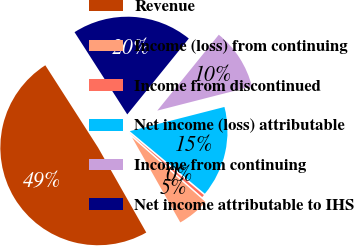Convert chart to OTSL. <chart><loc_0><loc_0><loc_500><loc_500><pie_chart><fcel>Revenue<fcel>Income (loss) from continuing<fcel>Income from discontinued<fcel>Net income (loss) attributable<fcel>Income from continuing<fcel>Net income attributable to IHS<nl><fcel>49.13%<fcel>5.3%<fcel>0.43%<fcel>15.04%<fcel>10.17%<fcel>19.91%<nl></chart> 